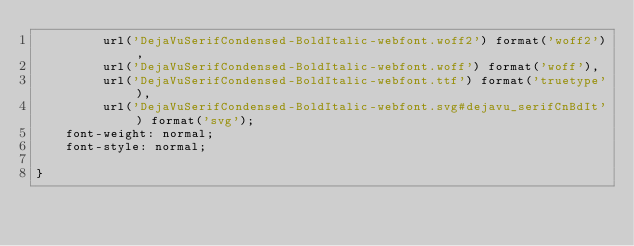Convert code to text. <code><loc_0><loc_0><loc_500><loc_500><_CSS_>         url('DejaVuSerifCondensed-BoldItalic-webfont.woff2') format('woff2'),
         url('DejaVuSerifCondensed-BoldItalic-webfont.woff') format('woff'),
         url('DejaVuSerifCondensed-BoldItalic-webfont.ttf') format('truetype'),
         url('DejaVuSerifCondensed-BoldItalic-webfont.svg#dejavu_serifCnBdIt') format('svg');
    font-weight: normal;
    font-style: normal;

}

</code> 